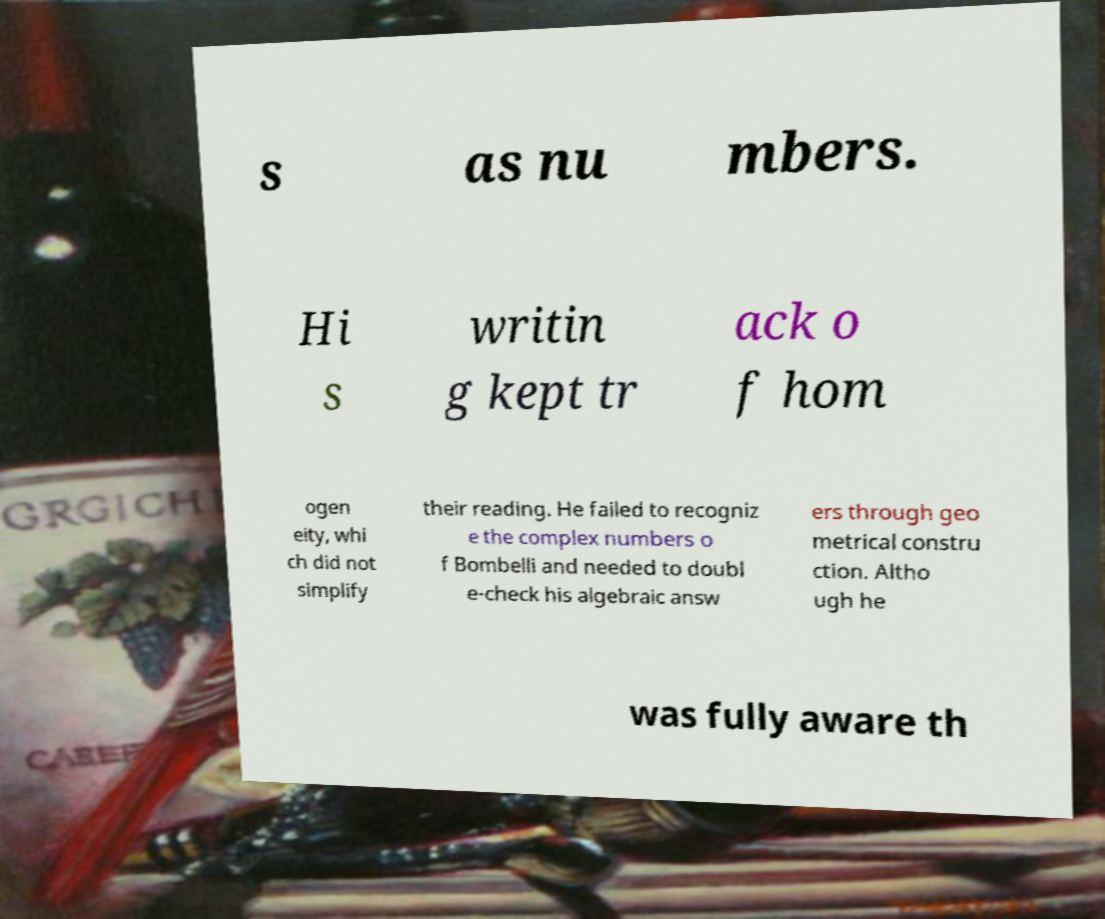Could you assist in decoding the text presented in this image and type it out clearly? s as nu mbers. Hi s writin g kept tr ack o f hom ogen eity, whi ch did not simplify their reading. He failed to recogniz e the complex numbers o f Bombelli and needed to doubl e-check his algebraic answ ers through geo metrical constru ction. Altho ugh he was fully aware th 